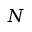Convert formula to latex. <formula><loc_0><loc_0><loc_500><loc_500>N</formula> 